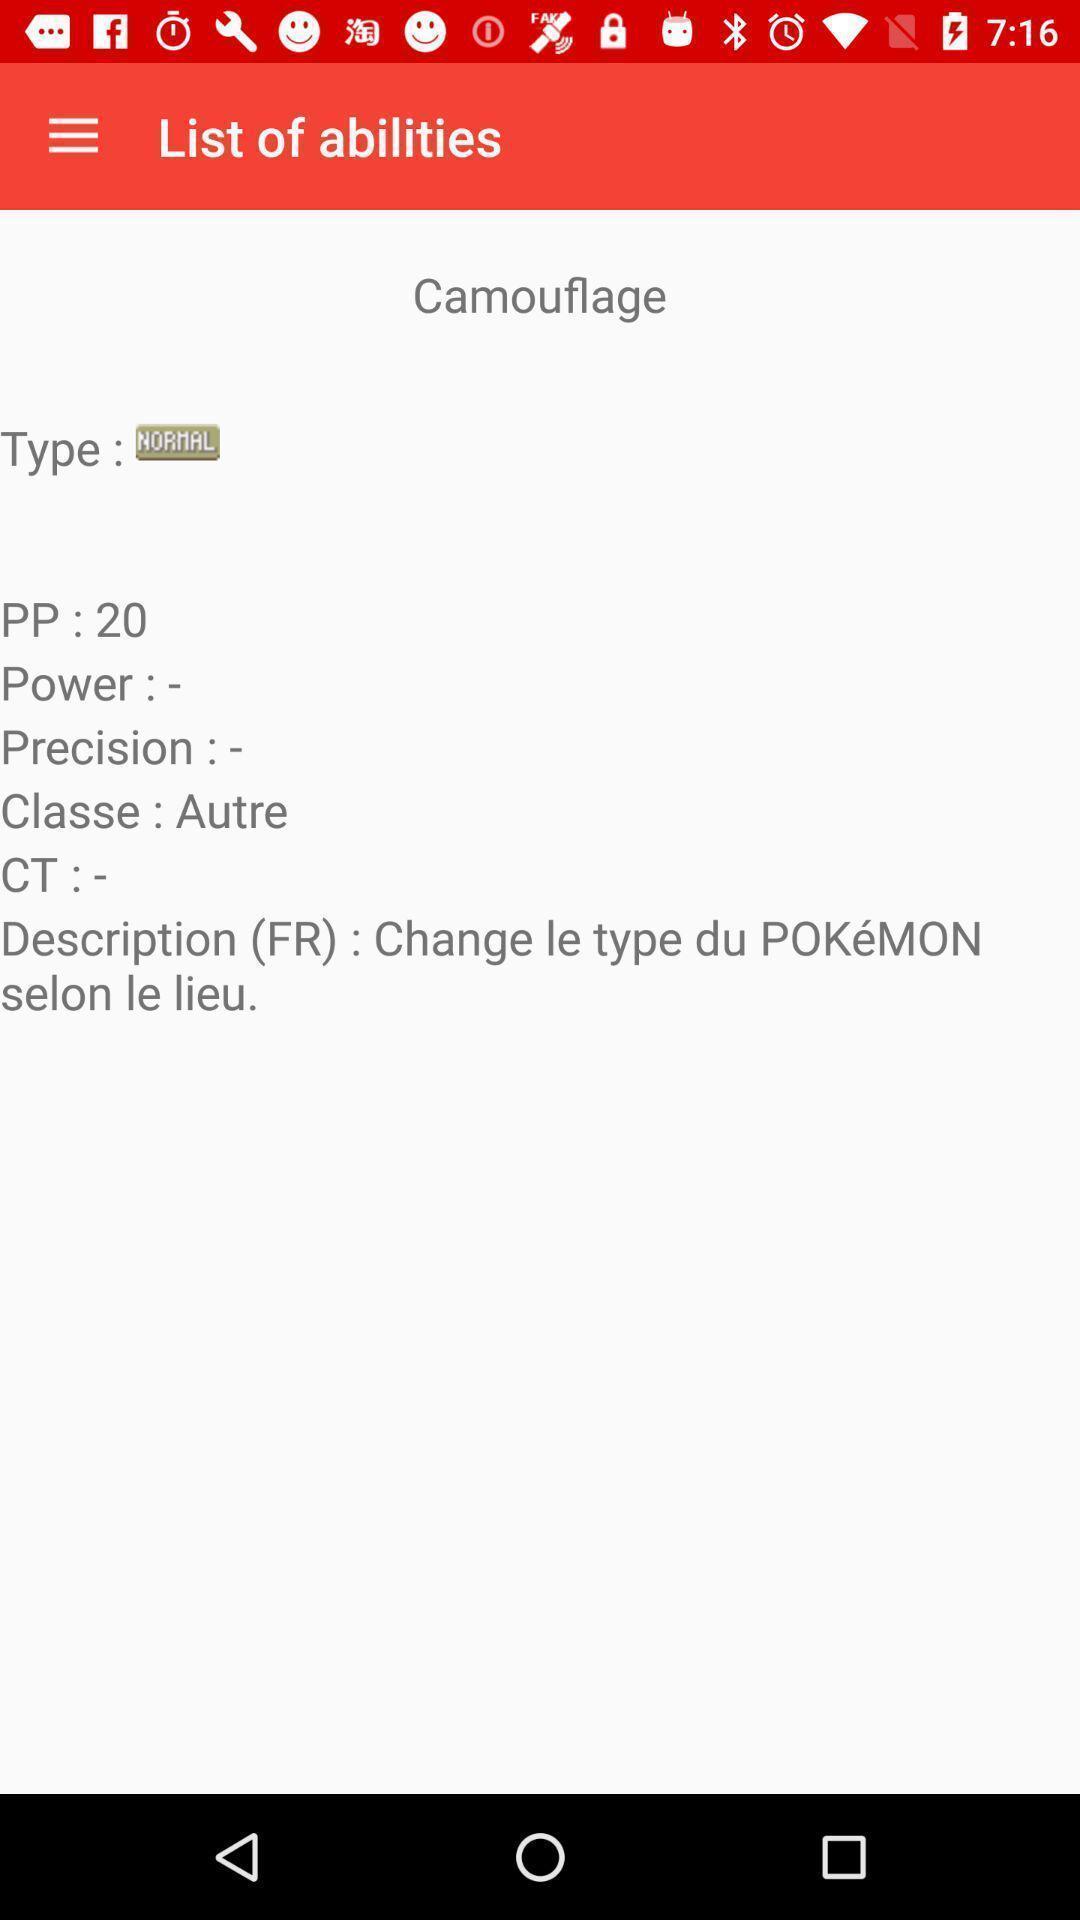Summarize the information in this screenshot. Various ability list displayed. 